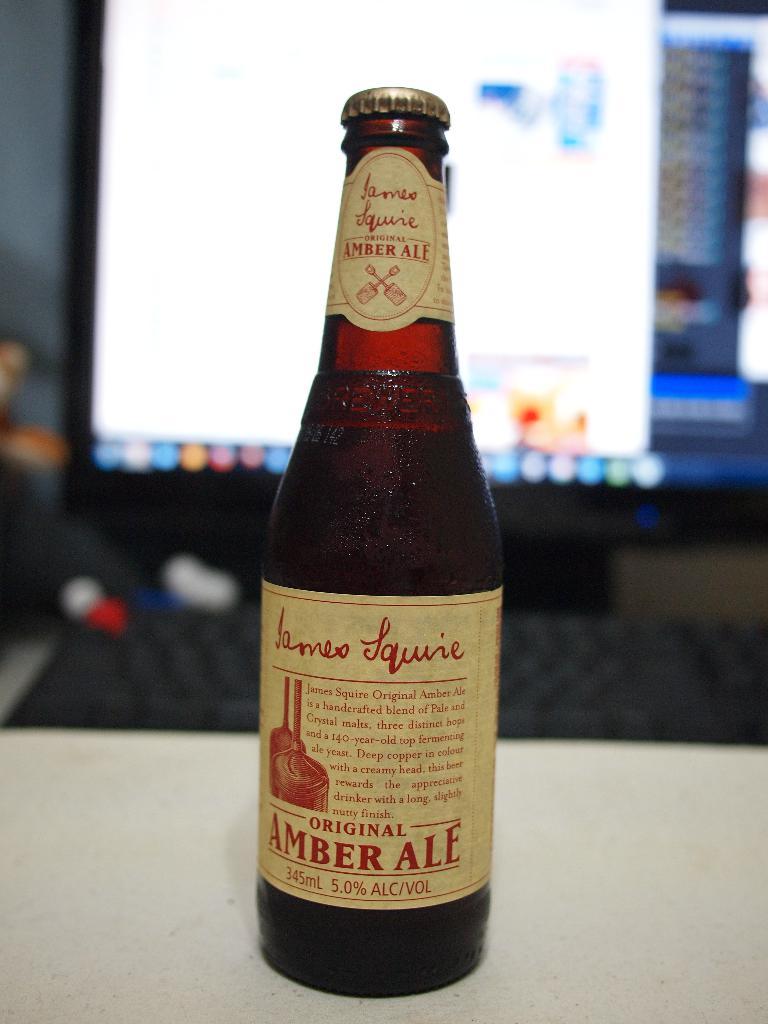What's the ale's alcohol percentage?
Ensure brevity in your answer.  5. What is the name of the ale?
Offer a terse response. James squire. 